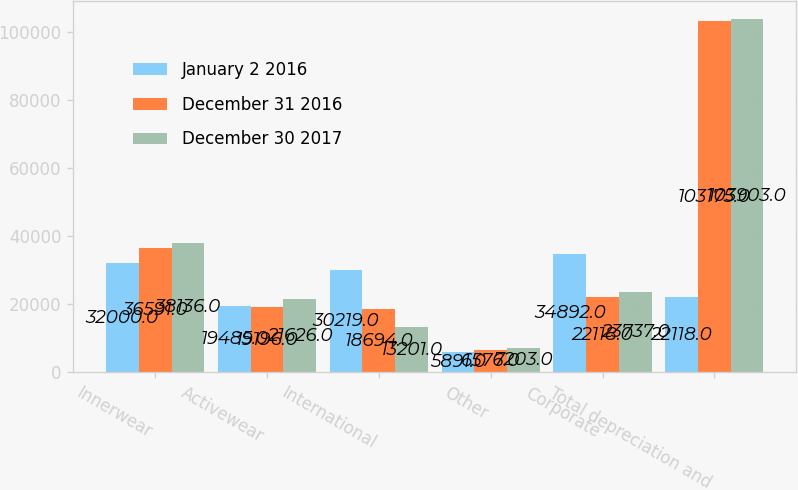Convert chart to OTSL. <chart><loc_0><loc_0><loc_500><loc_500><stacked_bar_chart><ecel><fcel>Innerwear<fcel>Activewear<fcel>International<fcel>Other<fcel>Corporate<fcel>Total depreciation and<nl><fcel>January 2 2016<fcel>32000<fcel>19485<fcel>30219<fcel>5891<fcel>34892<fcel>22118<nl><fcel>December 31 2016<fcel>36591<fcel>19196<fcel>18694<fcel>6576<fcel>22118<fcel>103175<nl><fcel>December 30 2017<fcel>38136<fcel>21626<fcel>13201<fcel>7203<fcel>23737<fcel>103903<nl></chart> 